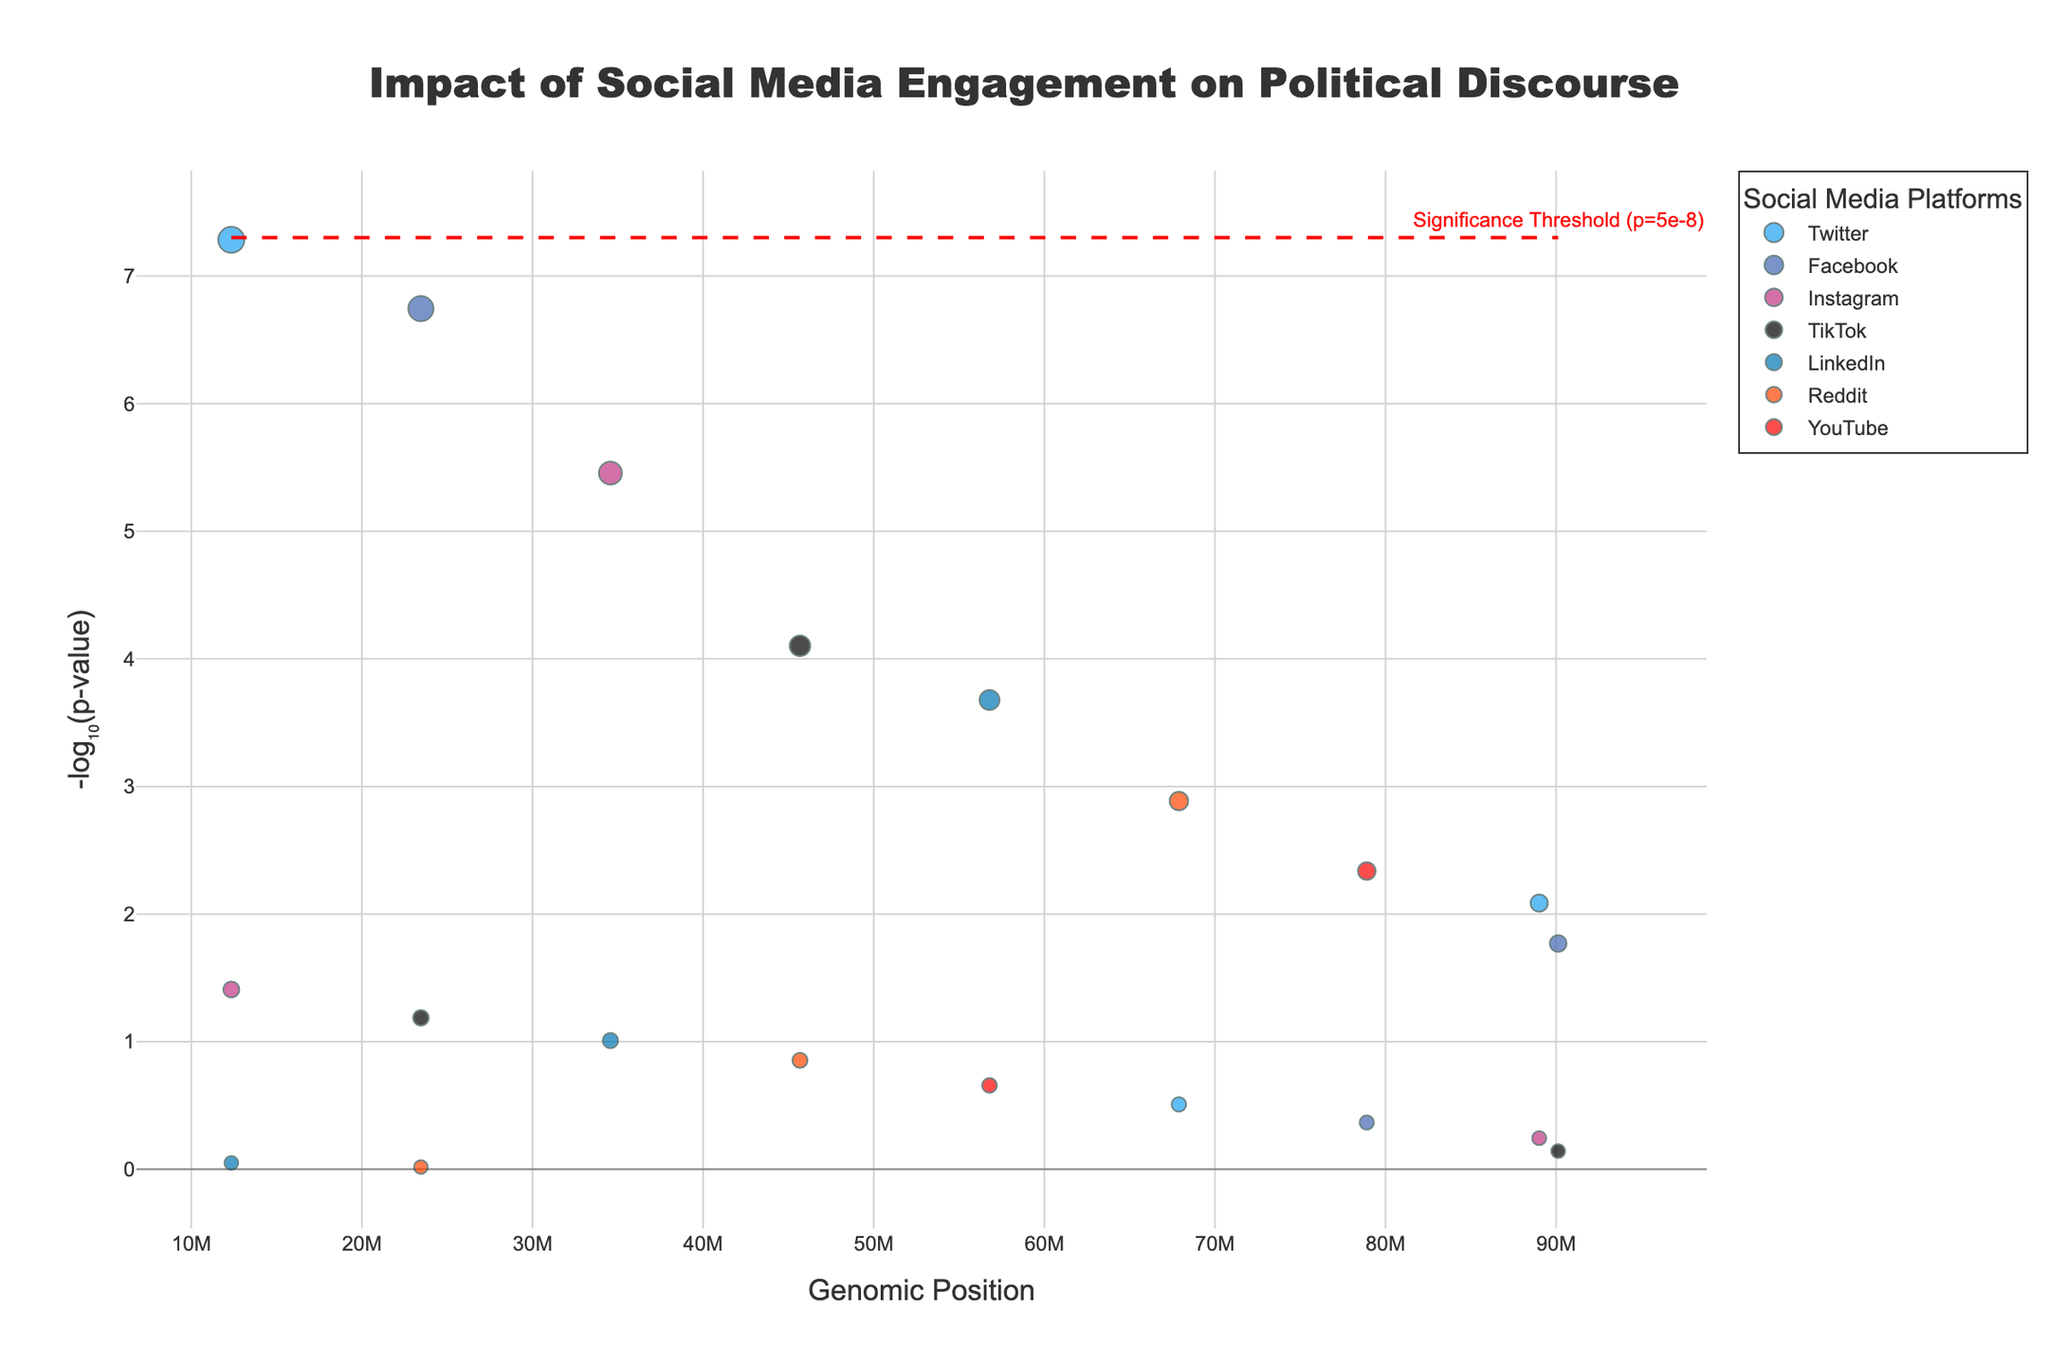How many different social media platforms are represented in the plot? By observing the legend or the data points, we can count the number of unique platforms displayed.
Answer: 7 Which platform shows the most statistically significant result? By examining the y-axis (which represents -log₁₀(p-value)) and finding the highest point, we can identify the platform with the lowest p-value.
Answer: Twitter What is the significance threshold line set at? By looking at the red dashed line and its annotation in the plot, we can identify the p-value threshold it signifies.
Answer: 5e-8 Which demographic group corresponds to the highest point in the plot? By checking the hovertext information for the highest y-value point, we can identify the corresponding demographic.
Answer: 18-24 How does Instagram engagement impact 25-34-year-olds compared to 45-54-year-olds in terms of statistical significance? We can compare the height of the data points representing Instagram for both 25-34 and 45-54 demographic groups. The higher the point, the more statistically significant the result.
Answer: More significant for 25-34 Which platforms have data points below the significance threshold? We can identify these platforms by looking for data points that are above the red horizontal threshold line.
Answer: Twitter, Facebook Are there any platforms with no significant results? We can find this by noting which platforms only have data points below the significance threshold line.
Answer: LinkedIn, Reddit Which social media platform shows significant engagement impact across the largest number of demographic groups? By counting the number of demographic groups with significant data points for each platform, we can identify the platform with the most widespread impact.
Answer: Twitter Between Facebook and YouTube, which has a lower average p-value? By averaging the y-values (-log₁₀(p-value)) of data points for Facebook and YouTube, we can compare their average statistical significance. Facebook has more data points; average -log₁₀(p) for Facebook = (-log10(1.8e-7) + -log10(1.7e-2) + -log10(4.3e-1)) / 3, and for YouTube = (-log10(4.6e-3) + -log10(2.2e-1)) / 2. Comparing both averages gives the answer.
Answer: Facebook Is there a demographic group with significant engagement impact on multiple platforms? By looking at the data points above the threshold line and noting their demographic information, we can identify if the same demographic appears multiple times.
Answer: 18-24 